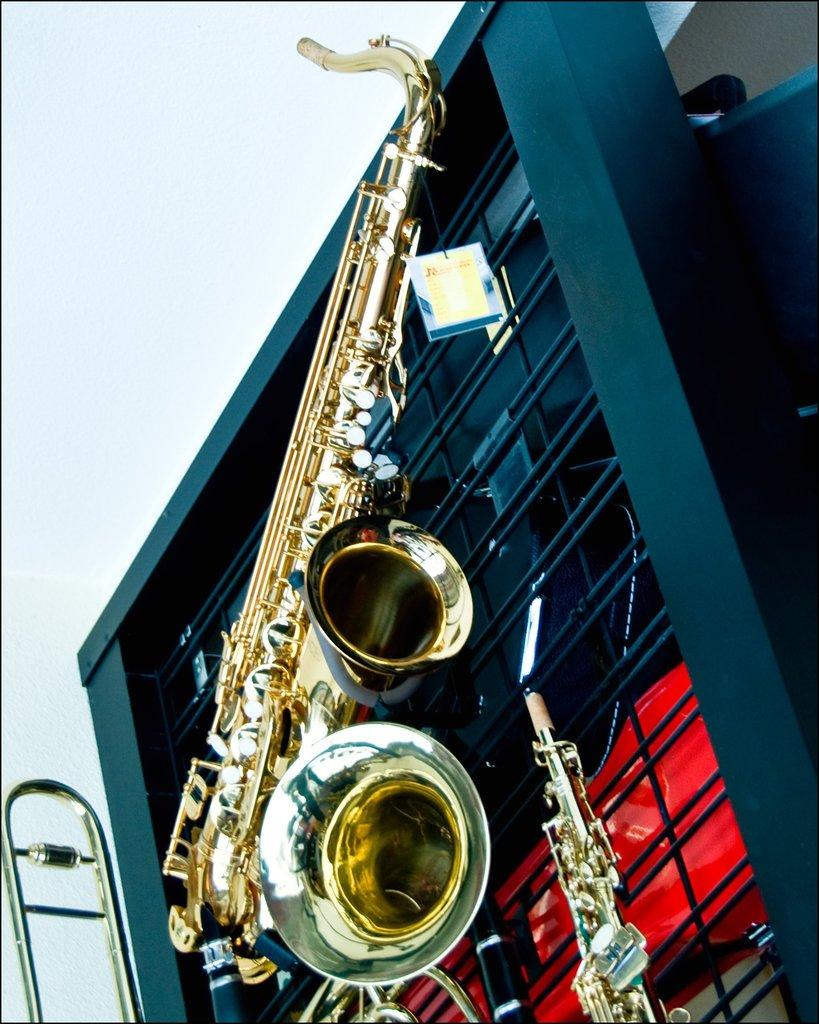What musical instrument is visible in the image? There is a saxophone in the image. Where is the saxophone placed? The saxophone is placed on something. Can you describe the setting of the image? The image appears to be in a store. What type of box is the saxophone playing in the image? There is no box present in the image, nor is the saxophone playing. 